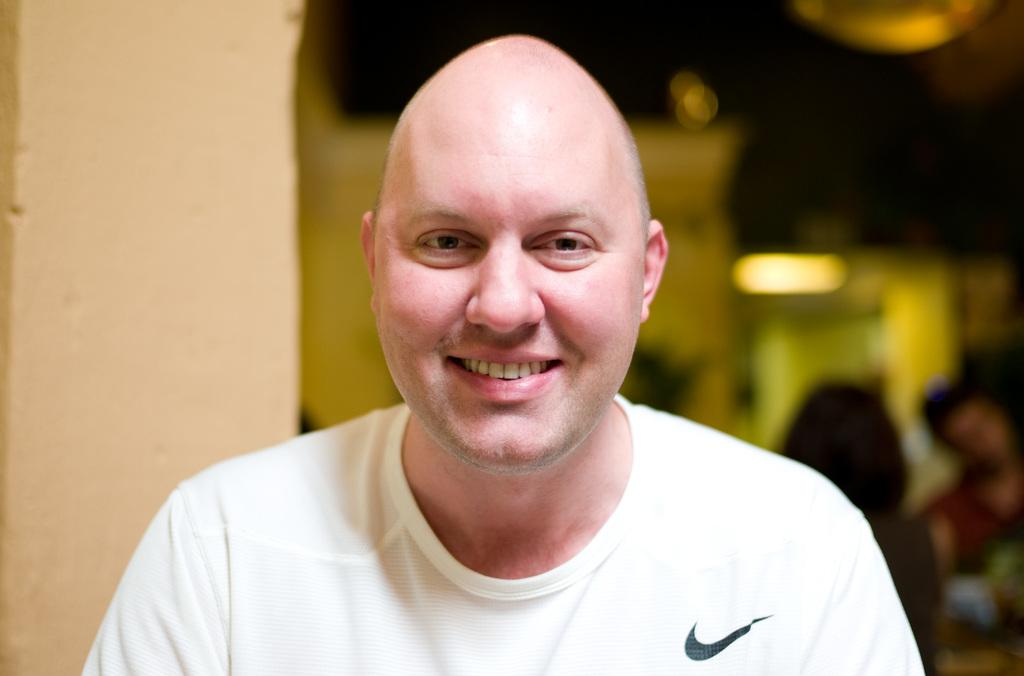What is the main subject of the image? There is a close-up picture of a man in the image. What can be observed about the man's attire? The man is wearing clothes. What is the man's facial expression in the image? The man is smiling. How is the background of the image depicted? The background of the image is blurred. What type of clouds can be seen in the man's mind in the image? There are no clouds visible in the image, and the man's mind is not depicted. 